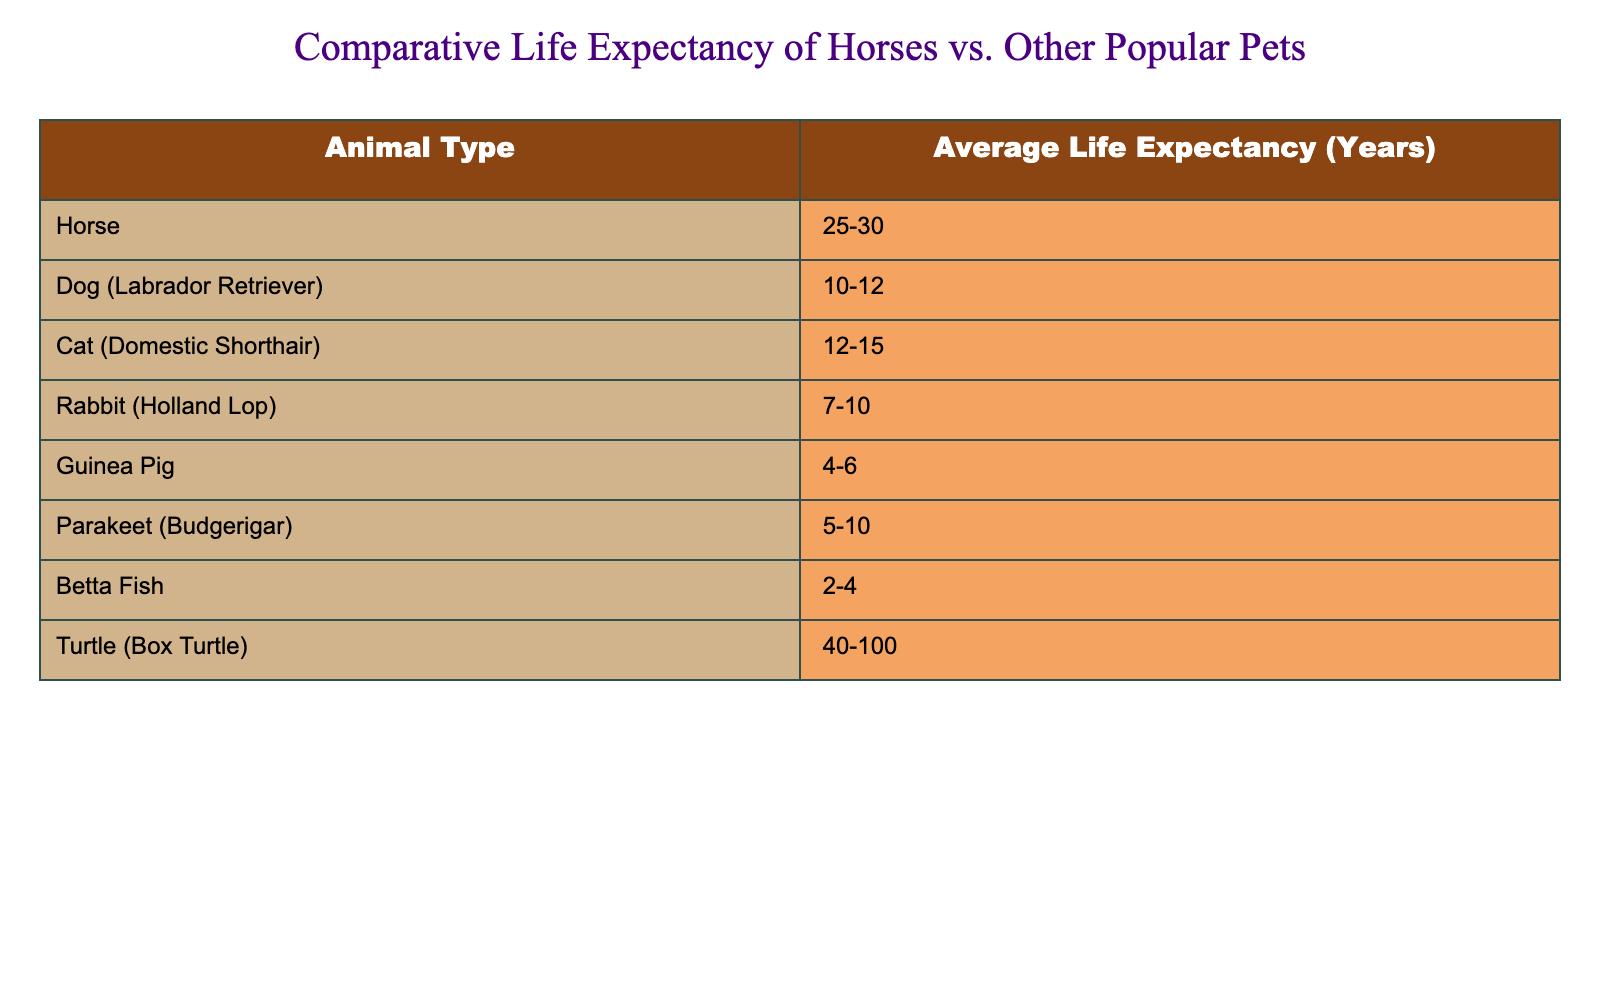What is the average life expectancy of a horse? The table states that the average life expectancy of a horse is 25-30 years. This means that horses typically live between these two values.
Answer: 25-30 years What is the average life expectancy range for a dog (Labrador Retriever)? According to the table, the average life expectancy for a Labrador Retriever is between 10-12 years. This range is given directly in the table.
Answer: 10-12 years Which animals in the table have a life expectancy greater than 20 years? Horses have a life expectancy of 25-30 years, and turtles can live for 40-100 years. These two values exceed 20 years based on the table.
Answer: Horse, Turtle Is the life expectancy of a guinea pig more than that of a rabbit? Looking at the table, the life expectancy of a guinea pig is 4-6 years, while for a rabbit, it’s 7-10 years. Since 4-6 is less than 7-10, the answer is no.
Answer: No What is the average life expectancy of a parakeet (Budgerigar) compared to that of a cat (Domestic Shorthair)? The average life expectancy of a parakeet is 5-10 years, and for a cat, it is 12-15 years. Cats live longer than parakeets, as the upper range of parakeets (10 years) is less than the lower range of cats (12 years).
Answer: Cats live longer than parakeets What is the total range of life expectancy for dogs (Labrador Retriever) and cats (Domestic Shorthair)? The average life expectancy for dogs is 10-12 years, and for cats is 12-15 years. When combined, the lowest point is 10 years (from dogs) and the highest is 15 years (from cats), creating a total range from 10-15 years.
Answer: 10-15 years Which pet has the shortest life expectancy according to the table? The table shows that the Betta Fish has a life expectancy of 2-4 years, which is less than all the other animals listed. Therefore, Betta Fish has the shortest life expectancy.
Answer: Betta Fish How does the average life expectancy of turtles compare to that of horses? Turtles have a life expectancy range of 40-100 years, while horses have an average of 25-30 years. Since the lower limit for turtles (40 years) is greater than the upper limit for horses (30 years), turtles live significantly longer.
Answer: Turtles live significantly longer than horses 